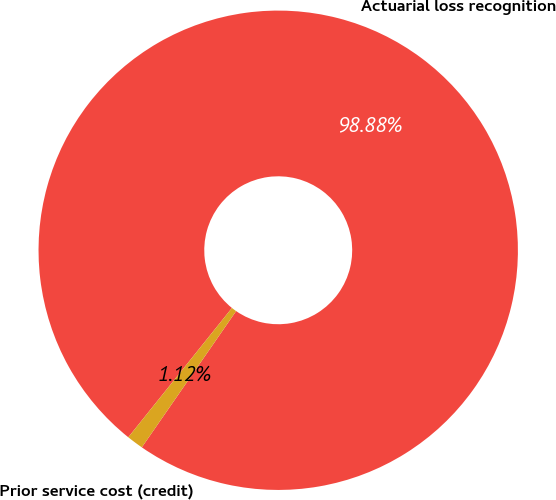Convert chart to OTSL. <chart><loc_0><loc_0><loc_500><loc_500><pie_chart><fcel>Actuarial loss recognition<fcel>Prior service cost (credit)<nl><fcel>98.88%<fcel>1.12%<nl></chart> 